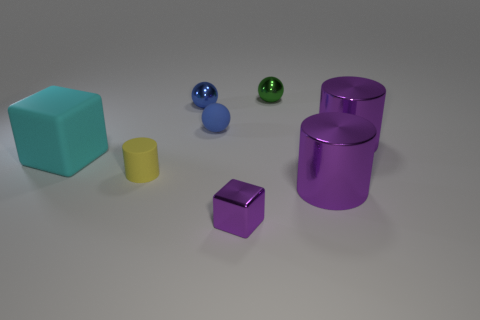There is a large thing that is on the left side of the small shiny block; does it have the same color as the small cylinder?
Provide a succinct answer. No. What shape is the object that is both behind the tiny matte ball and left of the small shiny cube?
Keep it short and to the point. Sphere. There is a tiny shiny object that is in front of the blue metal ball; what is its color?
Offer a very short reply. Purple. Are there any other things of the same color as the small matte cylinder?
Offer a very short reply. No. Does the blue metal object have the same size as the purple cube?
Provide a succinct answer. Yes. What is the size of the sphere that is behind the tiny blue rubber object and in front of the small green metal ball?
Keep it short and to the point. Small. What number of tiny purple things are made of the same material as the tiny block?
Your answer should be compact. 0. What shape is the object that is the same color as the tiny rubber ball?
Make the answer very short. Sphere. The tiny metal cube is what color?
Give a very brief answer. Purple. There is a purple thing that is left of the green thing; is its shape the same as the yellow object?
Offer a terse response. No. 